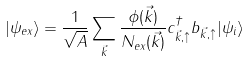Convert formula to latex. <formula><loc_0><loc_0><loc_500><loc_500>| \psi _ { e x } \rangle = \frac { 1 } { \sqrt { A } } \sum _ { \vec { k } } \frac { \phi ( \vec { k } ) } { N _ { e x } ( \vec { k } ) } c _ { \vec { k } , \uparrow } ^ { \dagger } b _ { \vec { k } , \uparrow } | \psi _ { i } \rangle</formula> 